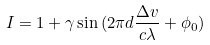Convert formula to latex. <formula><loc_0><loc_0><loc_500><loc_500>I = 1 + \gamma \sin { ( 2 \pi d \frac { \Delta v } { c \lambda } + \phi _ { 0 } } )</formula> 